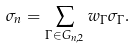<formula> <loc_0><loc_0><loc_500><loc_500>\sigma _ { n } = \sum _ { \Gamma \in G _ { n , 2 } } w _ { \Gamma } \sigma _ { \Gamma } .</formula> 